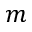<formula> <loc_0><loc_0><loc_500><loc_500>m</formula> 